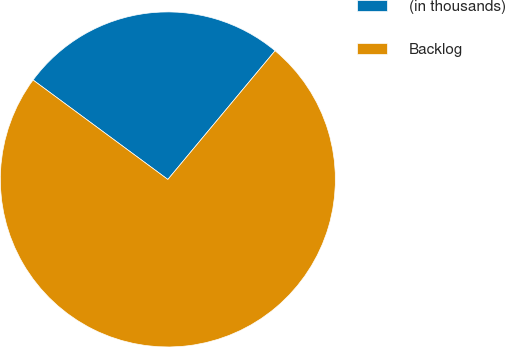Convert chart. <chart><loc_0><loc_0><loc_500><loc_500><pie_chart><fcel>(in thousands)<fcel>Backlog<nl><fcel>25.94%<fcel>74.06%<nl></chart> 